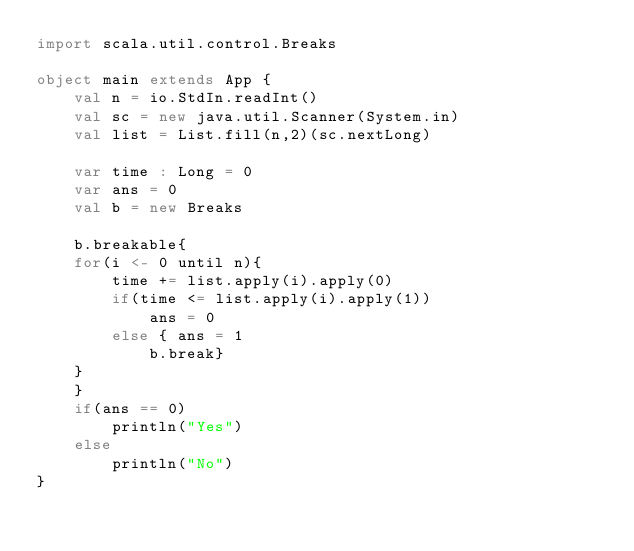<code> <loc_0><loc_0><loc_500><loc_500><_Scala_>import scala.util.control.Breaks

object main extends App {
    val n = io.StdIn.readInt()
    val sc = new java.util.Scanner(System.in)
    val list = List.fill(n,2)(sc.nextLong)

    var time : Long = 0
    var ans = 0
    val b = new Breaks

    b.breakable{
    for(i <- 0 until n){
        time += list.apply(i).apply(0)
        if(time <= list.apply(i).apply(1))
            ans = 0
        else { ans = 1
            b.break}
    }
    }
    if(ans == 0)
        println("Yes")
    else
        println("No")
}</code> 